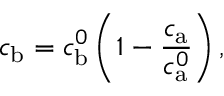Convert formula to latex. <formula><loc_0><loc_0><loc_500><loc_500>c _ { b } = c _ { b } ^ { 0 } \left ( 1 - \frac { c _ { a } } { c _ { a } ^ { 0 } } \right ) ,</formula> 